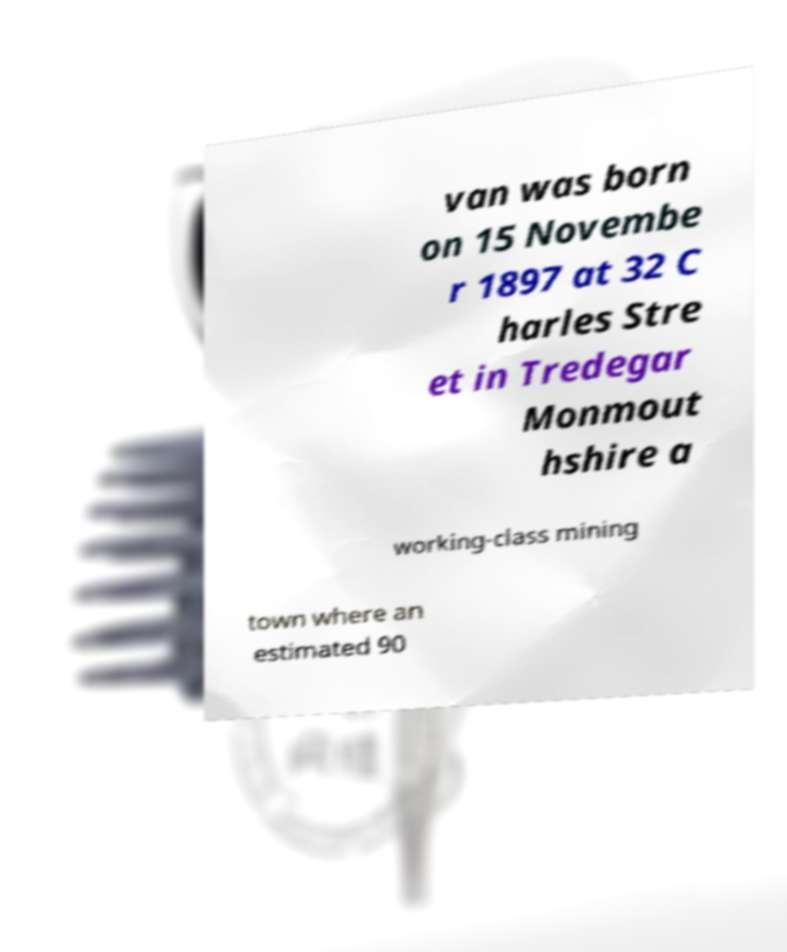Could you assist in decoding the text presented in this image and type it out clearly? van was born on 15 Novembe r 1897 at 32 C harles Stre et in Tredegar Monmout hshire a working-class mining town where an estimated 90 